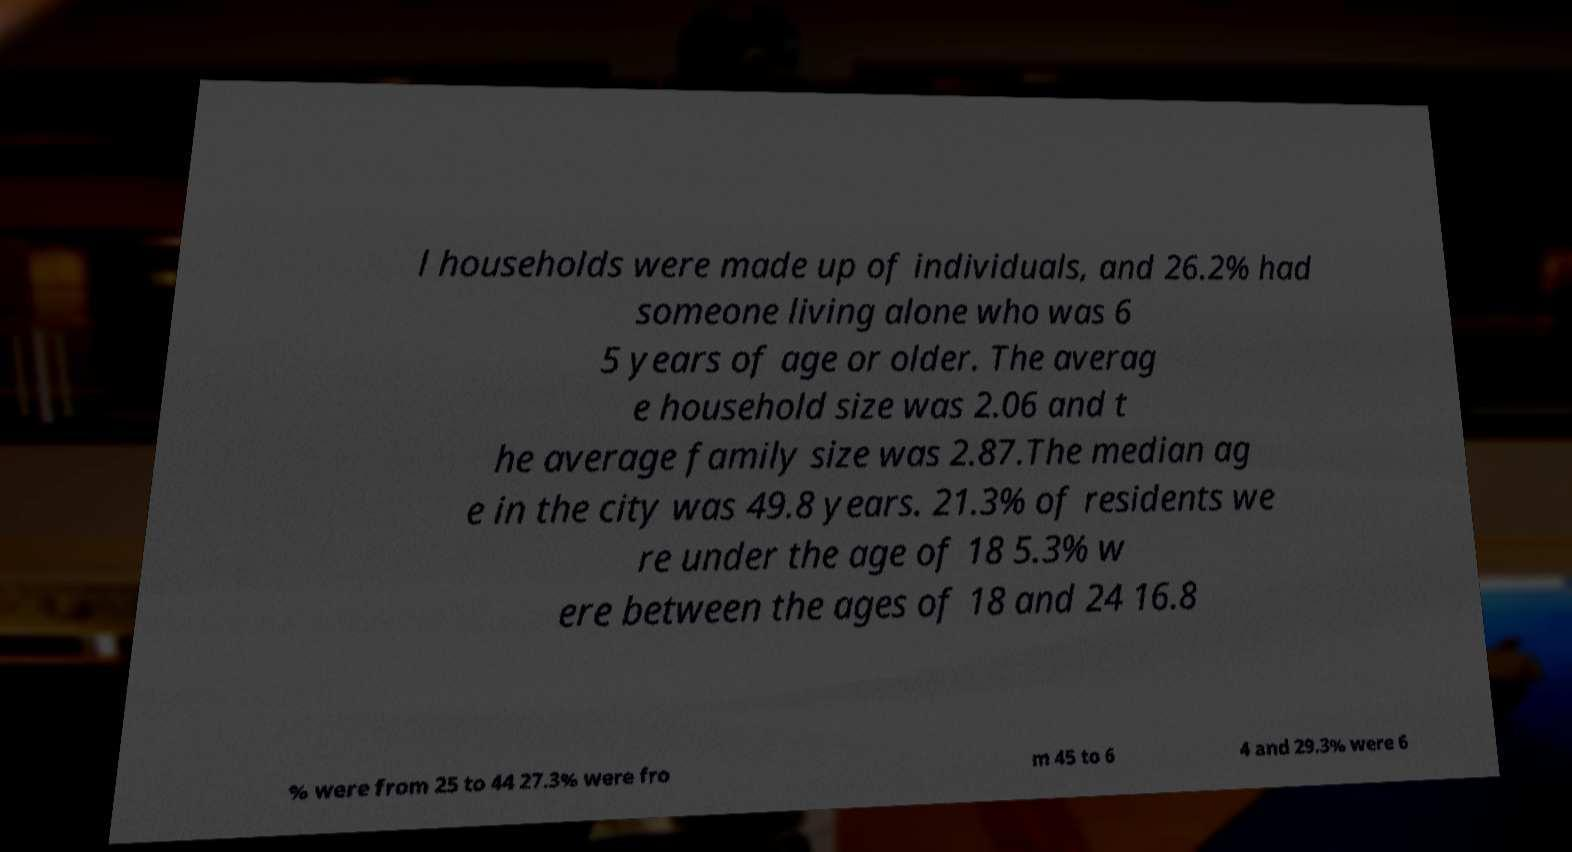Please identify and transcribe the text found in this image. l households were made up of individuals, and 26.2% had someone living alone who was 6 5 years of age or older. The averag e household size was 2.06 and t he average family size was 2.87.The median ag e in the city was 49.8 years. 21.3% of residents we re under the age of 18 5.3% w ere between the ages of 18 and 24 16.8 % were from 25 to 44 27.3% were fro m 45 to 6 4 and 29.3% were 6 